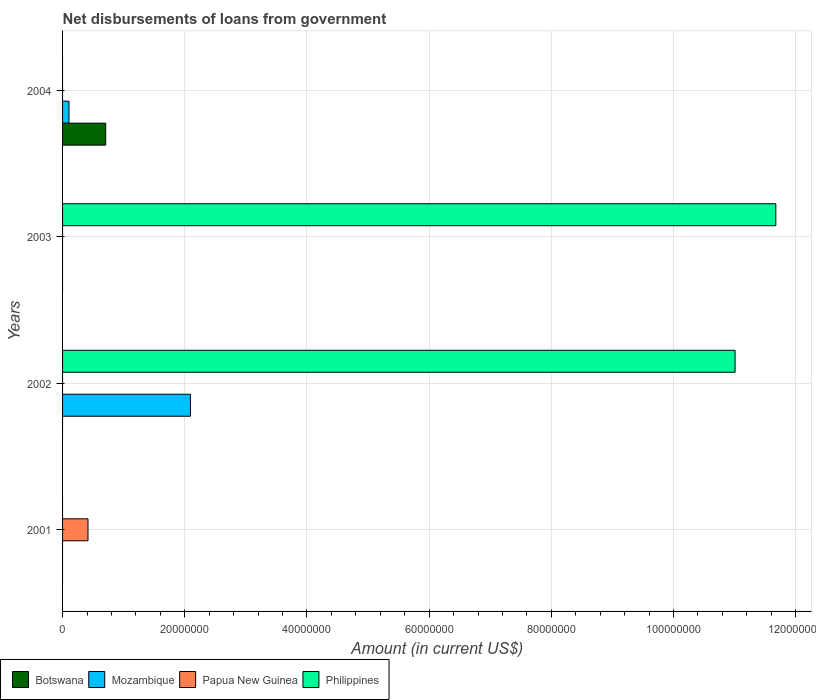How many different coloured bars are there?
Your answer should be compact. 4. Are the number of bars per tick equal to the number of legend labels?
Provide a short and direct response. No. What is the label of the 3rd group of bars from the top?
Your response must be concise. 2002. What is the amount of loan disbursed from government in Botswana in 2002?
Offer a terse response. 0. Across all years, what is the maximum amount of loan disbursed from government in Botswana?
Your answer should be very brief. 7.06e+06. What is the total amount of loan disbursed from government in Botswana in the graph?
Provide a succinct answer. 7.06e+06. What is the difference between the amount of loan disbursed from government in Philippines in 2004 and the amount of loan disbursed from government in Botswana in 2001?
Keep it short and to the point. 0. What is the average amount of loan disbursed from government in Papua New Guinea per year?
Your response must be concise. 1.04e+06. In the year 2004, what is the difference between the amount of loan disbursed from government in Botswana and amount of loan disbursed from government in Mozambique?
Give a very brief answer. 6.01e+06. What is the difference between the highest and the lowest amount of loan disbursed from government in Mozambique?
Ensure brevity in your answer.  2.09e+07. Is it the case that in every year, the sum of the amount of loan disbursed from government in Mozambique and amount of loan disbursed from government in Papua New Guinea is greater than the sum of amount of loan disbursed from government in Botswana and amount of loan disbursed from government in Philippines?
Offer a terse response. No. Is it the case that in every year, the sum of the amount of loan disbursed from government in Mozambique and amount of loan disbursed from government in Papua New Guinea is greater than the amount of loan disbursed from government in Philippines?
Offer a terse response. No. What is the difference between two consecutive major ticks on the X-axis?
Keep it short and to the point. 2.00e+07. Are the values on the major ticks of X-axis written in scientific E-notation?
Ensure brevity in your answer.  No. Does the graph contain any zero values?
Ensure brevity in your answer.  Yes. Does the graph contain grids?
Provide a succinct answer. Yes. How many legend labels are there?
Provide a succinct answer. 4. How are the legend labels stacked?
Offer a terse response. Horizontal. What is the title of the graph?
Ensure brevity in your answer.  Net disbursements of loans from government. Does "Cameroon" appear as one of the legend labels in the graph?
Give a very brief answer. No. What is the label or title of the X-axis?
Offer a very short reply. Amount (in current US$). What is the label or title of the Y-axis?
Your response must be concise. Years. What is the Amount (in current US$) in Botswana in 2001?
Your answer should be very brief. 0. What is the Amount (in current US$) of Papua New Guinea in 2001?
Your response must be concise. 4.16e+06. What is the Amount (in current US$) of Philippines in 2001?
Offer a terse response. 0. What is the Amount (in current US$) in Mozambique in 2002?
Provide a succinct answer. 2.09e+07. What is the Amount (in current US$) in Philippines in 2002?
Your response must be concise. 1.10e+08. What is the Amount (in current US$) in Botswana in 2003?
Provide a succinct answer. 0. What is the Amount (in current US$) of Philippines in 2003?
Your answer should be compact. 1.17e+08. What is the Amount (in current US$) in Botswana in 2004?
Keep it short and to the point. 7.06e+06. What is the Amount (in current US$) of Mozambique in 2004?
Your answer should be very brief. 1.05e+06. What is the Amount (in current US$) in Philippines in 2004?
Offer a very short reply. 0. Across all years, what is the maximum Amount (in current US$) in Botswana?
Provide a short and direct response. 7.06e+06. Across all years, what is the maximum Amount (in current US$) in Mozambique?
Offer a very short reply. 2.09e+07. Across all years, what is the maximum Amount (in current US$) of Papua New Guinea?
Provide a short and direct response. 4.16e+06. Across all years, what is the maximum Amount (in current US$) in Philippines?
Offer a terse response. 1.17e+08. Across all years, what is the minimum Amount (in current US$) of Papua New Guinea?
Make the answer very short. 0. Across all years, what is the minimum Amount (in current US$) of Philippines?
Keep it short and to the point. 0. What is the total Amount (in current US$) of Botswana in the graph?
Offer a very short reply. 7.06e+06. What is the total Amount (in current US$) of Mozambique in the graph?
Your response must be concise. 2.20e+07. What is the total Amount (in current US$) of Papua New Guinea in the graph?
Give a very brief answer. 4.16e+06. What is the total Amount (in current US$) in Philippines in the graph?
Offer a very short reply. 2.27e+08. What is the difference between the Amount (in current US$) in Philippines in 2002 and that in 2003?
Make the answer very short. -6.67e+06. What is the difference between the Amount (in current US$) in Mozambique in 2002 and that in 2004?
Keep it short and to the point. 1.99e+07. What is the difference between the Amount (in current US$) of Papua New Guinea in 2001 and the Amount (in current US$) of Philippines in 2002?
Your answer should be compact. -1.06e+08. What is the difference between the Amount (in current US$) in Papua New Guinea in 2001 and the Amount (in current US$) in Philippines in 2003?
Provide a short and direct response. -1.13e+08. What is the difference between the Amount (in current US$) of Mozambique in 2002 and the Amount (in current US$) of Philippines in 2003?
Ensure brevity in your answer.  -9.58e+07. What is the average Amount (in current US$) of Botswana per year?
Make the answer very short. 1.77e+06. What is the average Amount (in current US$) of Mozambique per year?
Your answer should be very brief. 5.50e+06. What is the average Amount (in current US$) of Papua New Guinea per year?
Your response must be concise. 1.04e+06. What is the average Amount (in current US$) in Philippines per year?
Provide a short and direct response. 5.67e+07. In the year 2002, what is the difference between the Amount (in current US$) of Mozambique and Amount (in current US$) of Philippines?
Offer a terse response. -8.91e+07. In the year 2004, what is the difference between the Amount (in current US$) of Botswana and Amount (in current US$) of Mozambique?
Give a very brief answer. 6.01e+06. What is the ratio of the Amount (in current US$) in Philippines in 2002 to that in 2003?
Offer a terse response. 0.94. What is the ratio of the Amount (in current US$) in Mozambique in 2002 to that in 2004?
Make the answer very short. 19.87. What is the difference between the highest and the lowest Amount (in current US$) in Botswana?
Your answer should be very brief. 7.06e+06. What is the difference between the highest and the lowest Amount (in current US$) in Mozambique?
Your answer should be compact. 2.09e+07. What is the difference between the highest and the lowest Amount (in current US$) in Papua New Guinea?
Provide a succinct answer. 4.16e+06. What is the difference between the highest and the lowest Amount (in current US$) in Philippines?
Ensure brevity in your answer.  1.17e+08. 